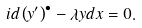Convert formula to latex. <formula><loc_0><loc_0><loc_500><loc_500>i d \left ( y ^ { \prime } \right ) ^ { \bullet } - \lambda y d x = 0 .</formula> 